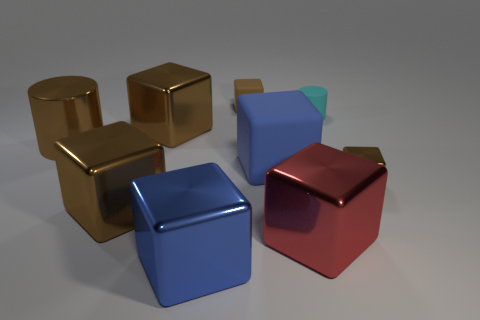There is a tiny matte object on the left side of the tiny cyan cylinder; are there any small brown things right of it?
Ensure brevity in your answer.  Yes. Are any things visible?
Offer a very short reply. Yes. What color is the big cylinder on the left side of the cylinder that is on the right side of the blue rubber cube?
Offer a terse response. Brown. There is another large thing that is the same shape as the cyan object; what material is it?
Ensure brevity in your answer.  Metal. How many blue matte blocks are the same size as the brown matte cube?
Offer a very short reply. 0. What is the size of the blue cube that is made of the same material as the brown cylinder?
Your response must be concise. Large. How many large brown shiny objects are the same shape as the small cyan rubber thing?
Keep it short and to the point. 1. What number of big blue metal cylinders are there?
Make the answer very short. 0. Is the shape of the big thing that is behind the metallic cylinder the same as  the blue rubber object?
Ensure brevity in your answer.  Yes. What material is the other blue cube that is the same size as the blue metal cube?
Ensure brevity in your answer.  Rubber. 